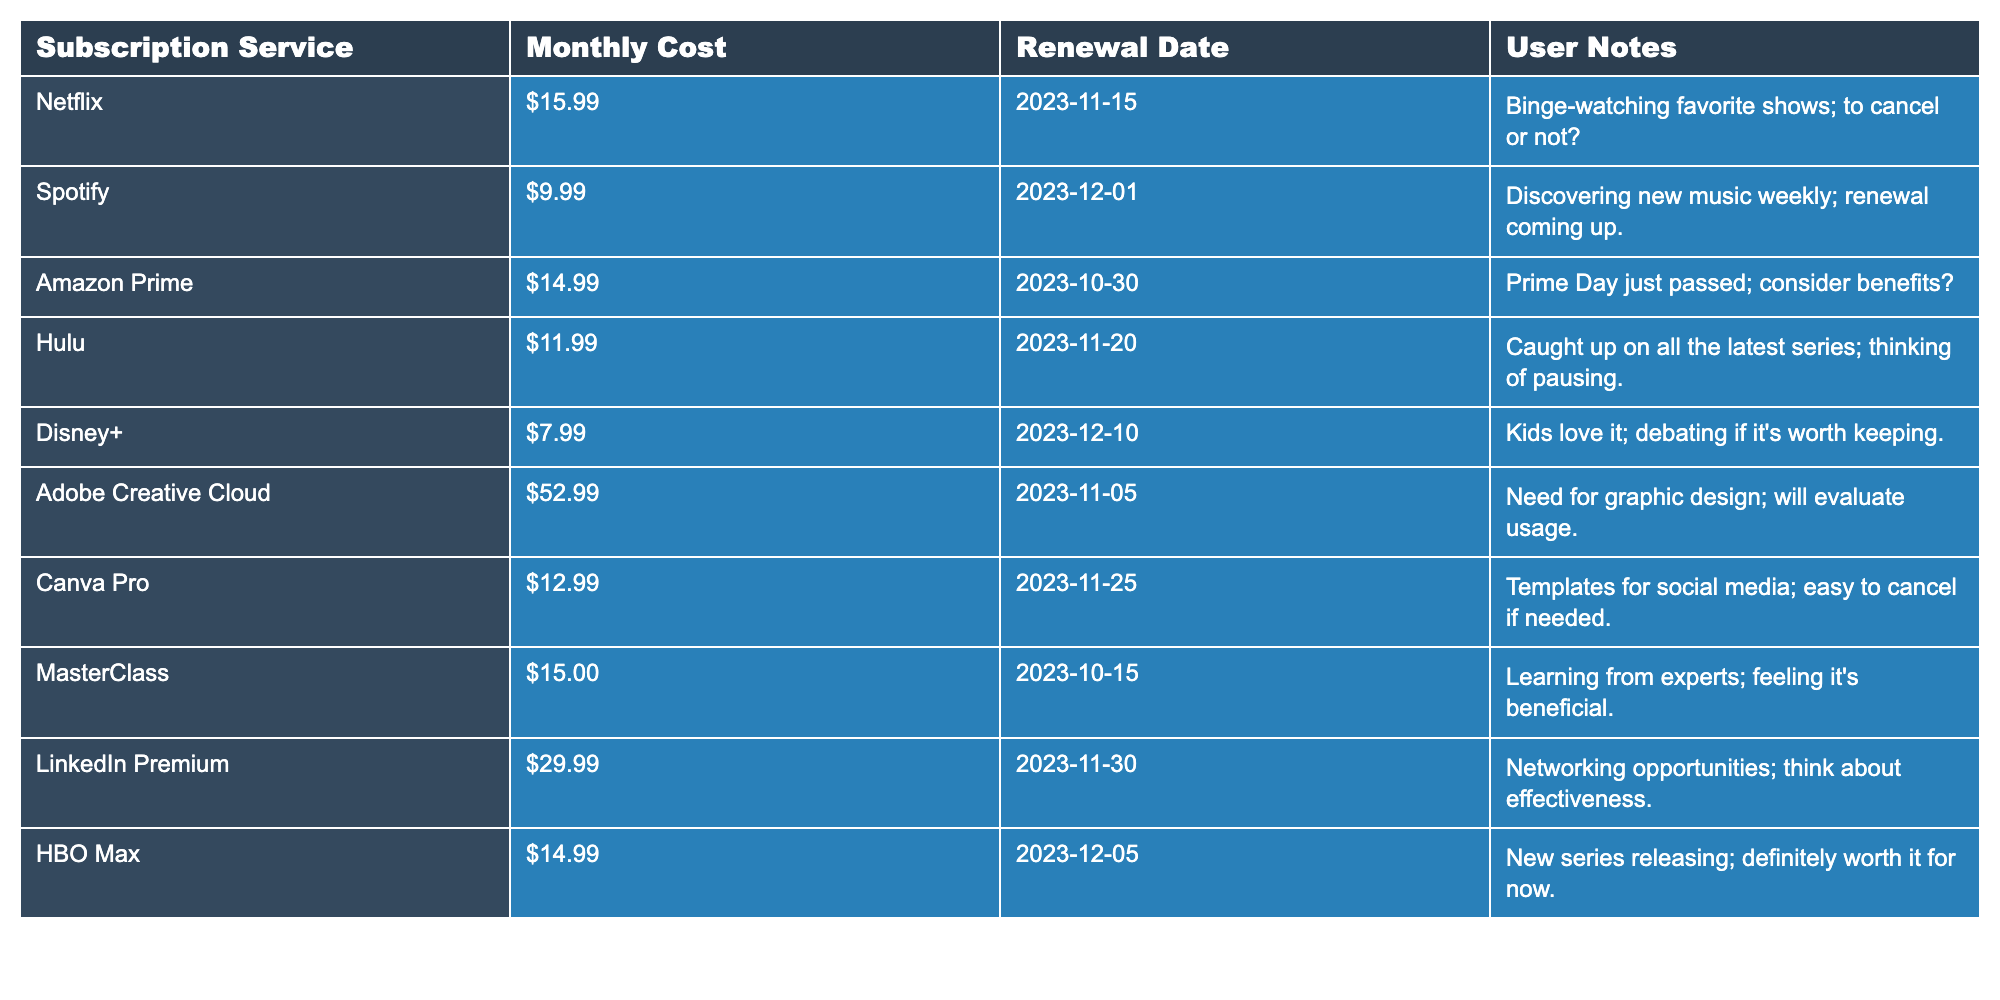What's the monthly cost of Hulu? The table lists Hulu's monthly cost under the "Monthly Cost" column, which shows that it is $11.99.
Answer: $11.99 What is the renewal date for Adobe Creative Cloud? Looking at the renewal date column for Adobe Creative Cloud, it states that the renewal date is 2023-11-05.
Answer: 2023-11-05 Which subscription has the highest monthly cost? Searching through the "Monthly Cost" column, Adobe Creative Cloud has the highest cost at $52.99.
Answer: Adobe Creative Cloud Are there any subscriptions that renew in December? The table shows renewal dates for subscriptions, and two services (Spotify and HBO Max) are set to renew in December.
Answer: Yes What is the total monthly cost for subscriptions that renew in November? The subscriptions that renew in November are Netflix ($15.99), Adobe Creative Cloud ($52.99), Hulu ($11.99), and Canva Pro ($12.99). Their total would be $15.99 + $52.99 + $11.99 + $12.99, which equals $93.96.
Answer: $93.96 How many subscriptions have a monthly cost greater than $15? Reviewing the 'Monthly Cost' column, the subscriptions that exceed $15 are Netflix ($15.99), Adobe Creative Cloud ($52.99), and LinkedIn Premium ($29.99). Thus, there are three subscriptions.
Answer: 3 Is Amazon Prime set to renew before the end of October? The renewal date for Amazon Prime is 2023-10-30, which is indeed before the end of October.
Answer: Yes What is the average monthly cost of all subscriptions listed? To calculate the average, we sum the costs ($15.99 + $9.99 + $14.99 + $11.99 + $7.99 + $52.99 + $12.99 + $15 + $29.99 + $14.99) = $210.92, then divide by the total number of subscriptions (10), resulting in an average cost of $21.09.
Answer: $21.09 Which subscription service has the latest renewal date? By examining the "Renewal Date" column, Disney+ has a renewal date of 2023-12-10, which is the latest among all subscriptions.
Answer: Disney+ How many subscriptions are noted for keeping or canceling? Checking the "User Notes" column, Hulu and Netflix are specifically debating whether to continue their subscriptions, thus there are two subscriptions noted for potential cancelation.
Answer: 2 